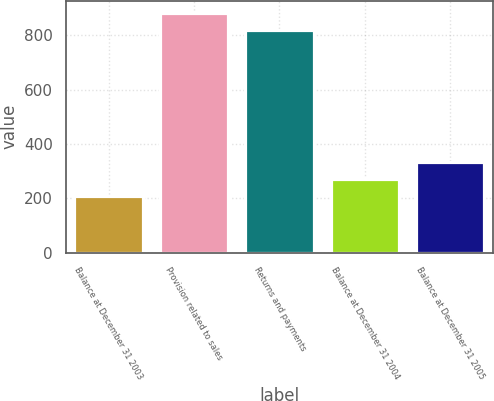Convert chart to OTSL. <chart><loc_0><loc_0><loc_500><loc_500><bar_chart><fcel>Balance at December 31 2003<fcel>Provision related to sales<fcel>Returns and payments<fcel>Balance at December 31 2004<fcel>Balance at December 31 2005<nl><fcel>208<fcel>883.5<fcel>820<fcel>271.5<fcel>335<nl></chart> 